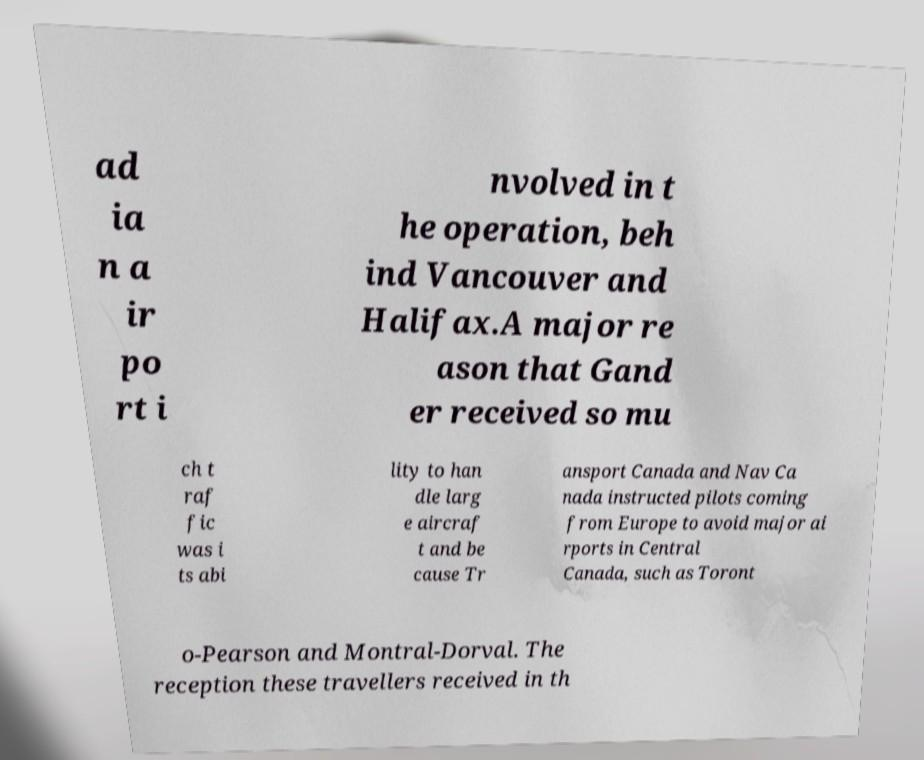Please read and relay the text visible in this image. What does it say? ad ia n a ir po rt i nvolved in t he operation, beh ind Vancouver and Halifax.A major re ason that Gand er received so mu ch t raf fic was i ts abi lity to han dle larg e aircraf t and be cause Tr ansport Canada and Nav Ca nada instructed pilots coming from Europe to avoid major ai rports in Central Canada, such as Toront o-Pearson and Montral-Dorval. The reception these travellers received in th 